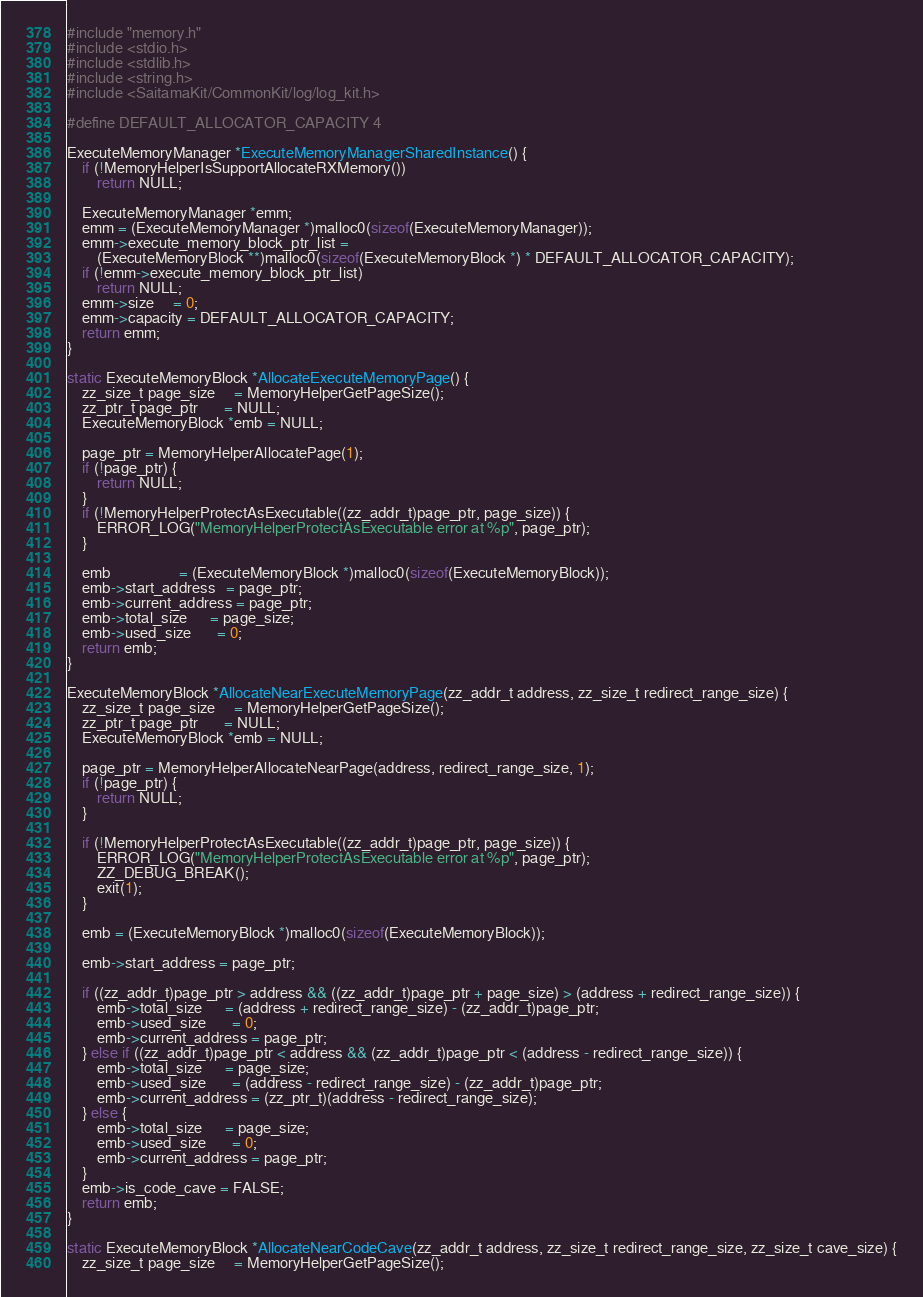<code> <loc_0><loc_0><loc_500><loc_500><_C_>#include "memory.h"
#include <stdio.h>
#include <stdlib.h>
#include <string.h>
#include <SaitamaKit/CommonKit/log/log_kit.h>

#define DEFAULT_ALLOCATOR_CAPACITY 4

ExecuteMemoryManager *ExecuteMemoryManagerSharedInstance() {
    if (!MemoryHelperIsSupportAllocateRXMemory())
        return NULL;

    ExecuteMemoryManager *emm;
    emm = (ExecuteMemoryManager *)malloc0(sizeof(ExecuteMemoryManager));
    emm->execute_memory_block_ptr_list =
        (ExecuteMemoryBlock **)malloc0(sizeof(ExecuteMemoryBlock *) * DEFAULT_ALLOCATOR_CAPACITY);
    if (!emm->execute_memory_block_ptr_list)
        return NULL;
    emm->size     = 0;
    emm->capacity = DEFAULT_ALLOCATOR_CAPACITY;
    return emm;
}

static ExecuteMemoryBlock *AllocateExecuteMemoryPage() {
    zz_size_t page_size     = MemoryHelperGetPageSize();
    zz_ptr_t page_ptr       = NULL;
    ExecuteMemoryBlock *emb = NULL;

    page_ptr = MemoryHelperAllocatePage(1);
    if (!page_ptr) {
        return NULL;
    }
    if (!MemoryHelperProtectAsExecutable((zz_addr_t)page_ptr, page_size)) {
        ERROR_LOG("MemoryHelperProtectAsExecutable error at %p", page_ptr);
    }

    emb                  = (ExecuteMemoryBlock *)malloc0(sizeof(ExecuteMemoryBlock));
    emb->start_address   = page_ptr;
    emb->current_address = page_ptr;
    emb->total_size      = page_size;
    emb->used_size       = 0;
    return emb;
}

ExecuteMemoryBlock *AllocateNearExecuteMemoryPage(zz_addr_t address, zz_size_t redirect_range_size) {
    zz_size_t page_size     = MemoryHelperGetPageSize();
    zz_ptr_t page_ptr       = NULL;
    ExecuteMemoryBlock *emb = NULL;

    page_ptr = MemoryHelperAllocateNearPage(address, redirect_range_size, 1);
    if (!page_ptr) {
        return NULL;
    }

    if (!MemoryHelperProtectAsExecutable((zz_addr_t)page_ptr, page_size)) {
        ERROR_LOG("MemoryHelperProtectAsExecutable error at %p", page_ptr);
        ZZ_DEBUG_BREAK();
        exit(1);
    }

    emb = (ExecuteMemoryBlock *)malloc0(sizeof(ExecuteMemoryBlock));

    emb->start_address = page_ptr;

    if ((zz_addr_t)page_ptr > address && ((zz_addr_t)page_ptr + page_size) > (address + redirect_range_size)) {
        emb->total_size      = (address + redirect_range_size) - (zz_addr_t)page_ptr;
        emb->used_size       = 0;
        emb->current_address = page_ptr;
    } else if ((zz_addr_t)page_ptr < address && (zz_addr_t)page_ptr < (address - redirect_range_size)) {
        emb->total_size      = page_size;
        emb->used_size       = (address - redirect_range_size) - (zz_addr_t)page_ptr;
        emb->current_address = (zz_ptr_t)(address - redirect_range_size);
    } else {
        emb->total_size      = page_size;
        emb->used_size       = 0;
        emb->current_address = page_ptr;
    }
    emb->is_code_cave = FALSE;
    return emb;
}

static ExecuteMemoryBlock *AllocateNearCodeCave(zz_addr_t address, zz_size_t redirect_range_size, zz_size_t cave_size) {
    zz_size_t page_size     = MemoryHelperGetPageSize();</code> 